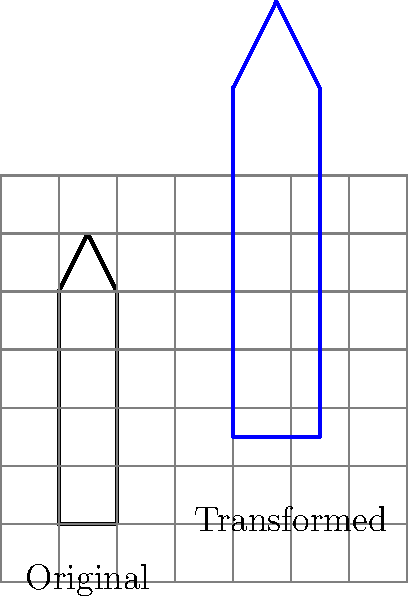As an aspiring artist inspired by Amelia Opdyke Jones's work with New York City landmarks, you're tasked with creating a stylized version of the Empire State Building for a poster. The original sketch is represented by the black outline, and you need to transform it to the blue outline. What sequence of transformations would you apply to achieve this result? Let's break down the transformation step-by-step:

1. Observe the original building (black outline) and the transformed building (blue outline).

2. Notice that the transformed building is larger and has moved to a new position.

3. To determine the scaling factor:
   - The original building is 4 units tall.
   - The transformed building is 6 units tall.
   - Scaling factor = 6/4 = 1.5

4. To determine the translation:
   - The bottom-left corner of the original building is at (0,0).
   - The bottom-left corner of the transformed building is at (2,1).
   - This indicates a translation of 2 units right and 1 unit up.

5. The order of transformations matters. In this case, we need to scale first and then translate. If we translated first, the subsequent scaling would affect the translation as well.

6. The correct sequence of transformations is:
   a. Scale by a factor of 1.5
   b. Translate 2 units right and 1 unit up

In mathematical notation, this can be expressed as:
$T(x,y) = (1.5x + 2, 1.5y + 1)$

Where $T(x,y)$ represents the transformed coordinates of any point $(x,y)$ in the original sketch.
Answer: Scale by 1.5, then translate (2,1) 